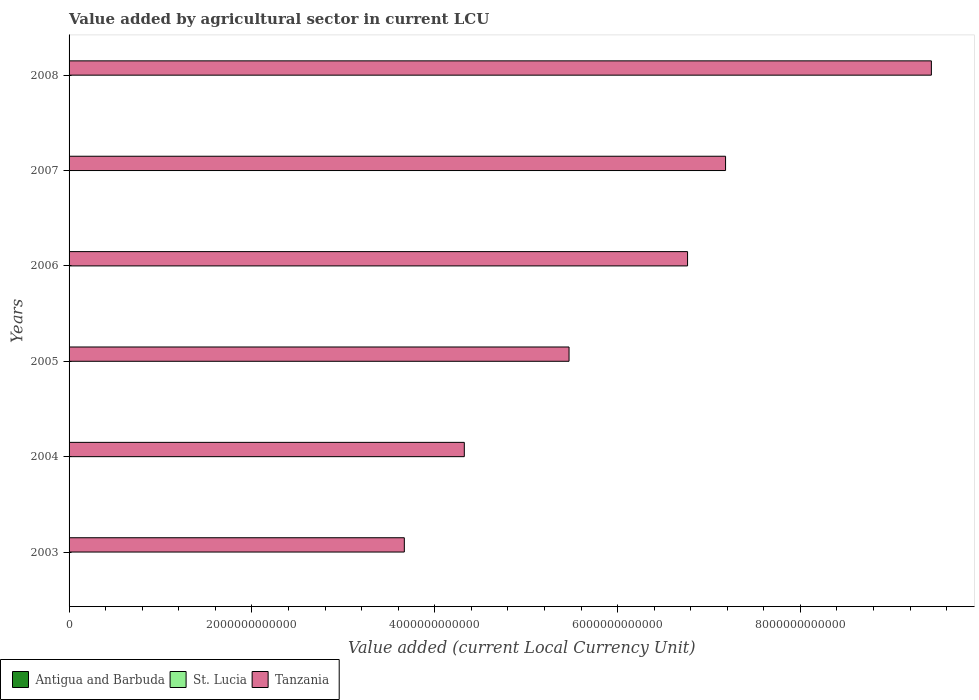How many different coloured bars are there?
Your answer should be very brief. 3. Are the number of bars per tick equal to the number of legend labels?
Your answer should be very brief. Yes. What is the label of the 3rd group of bars from the top?
Your answer should be very brief. 2006. What is the value added by agricultural sector in Antigua and Barbuda in 2005?
Your response must be concise. 4.85e+07. Across all years, what is the maximum value added by agricultural sector in Antigua and Barbuda?
Your response must be concise. 5.72e+07. Across all years, what is the minimum value added by agricultural sector in Tanzania?
Keep it short and to the point. 3.67e+12. What is the total value added by agricultural sector in Tanzania in the graph?
Provide a succinct answer. 3.68e+13. What is the difference between the value added by agricultural sector in St. Lucia in 2004 and that in 2008?
Provide a succinct answer. -2.80e+07. What is the difference between the value added by agricultural sector in St. Lucia in 2004 and the value added by agricultural sector in Antigua and Barbuda in 2007?
Make the answer very short. 3.47e+07. What is the average value added by agricultural sector in Tanzania per year?
Ensure brevity in your answer.  6.14e+12. In the year 2007, what is the difference between the value added by agricultural sector in Tanzania and value added by agricultural sector in Antigua and Barbuda?
Your response must be concise. 7.18e+12. What is the ratio of the value added by agricultural sector in St. Lucia in 2006 to that in 2007?
Provide a succinct answer. 1.01. Is the difference between the value added by agricultural sector in Tanzania in 2004 and 2008 greater than the difference between the value added by agricultural sector in Antigua and Barbuda in 2004 and 2008?
Provide a short and direct response. No. What is the difference between the highest and the second highest value added by agricultural sector in Antigua and Barbuda?
Give a very brief answer. 3.20e+05. What is the difference between the highest and the lowest value added by agricultural sector in St. Lucia?
Provide a succinct answer. 4.40e+07. What does the 2nd bar from the top in 2004 represents?
Ensure brevity in your answer.  St. Lucia. What does the 2nd bar from the bottom in 2008 represents?
Ensure brevity in your answer.  St. Lucia. Is it the case that in every year, the sum of the value added by agricultural sector in Antigua and Barbuda and value added by agricultural sector in St. Lucia is greater than the value added by agricultural sector in Tanzania?
Provide a succinct answer. No. How many bars are there?
Provide a succinct answer. 18. How many years are there in the graph?
Provide a succinct answer. 6. What is the difference between two consecutive major ticks on the X-axis?
Provide a short and direct response. 2.00e+12. Are the values on the major ticks of X-axis written in scientific E-notation?
Your answer should be compact. No. Does the graph contain any zero values?
Offer a terse response. No. Does the graph contain grids?
Your response must be concise. No. Where does the legend appear in the graph?
Your answer should be very brief. Bottom left. What is the title of the graph?
Offer a terse response. Value added by agricultural sector in current LCU. What is the label or title of the X-axis?
Your response must be concise. Value added (current Local Currency Unit). What is the label or title of the Y-axis?
Your response must be concise. Years. What is the Value added (current Local Currency Unit) in Antigua and Barbuda in 2003?
Your response must be concise. 4.04e+07. What is the Value added (current Local Currency Unit) in St. Lucia in 2003?
Provide a short and direct response. 8.72e+07. What is the Value added (current Local Currency Unit) in Tanzania in 2003?
Provide a succinct answer. 3.67e+12. What is the Value added (current Local Currency Unit) in Antigua and Barbuda in 2004?
Ensure brevity in your answer.  4.00e+07. What is the Value added (current Local Currency Unit) of St. Lucia in 2004?
Your response must be concise. 9.16e+07. What is the Value added (current Local Currency Unit) of Tanzania in 2004?
Your response must be concise. 4.32e+12. What is the Value added (current Local Currency Unit) of Antigua and Barbuda in 2005?
Keep it short and to the point. 4.85e+07. What is the Value added (current Local Currency Unit) in St. Lucia in 2005?
Give a very brief answer. 7.56e+07. What is the Value added (current Local Currency Unit) of Tanzania in 2005?
Give a very brief answer. 5.47e+12. What is the Value added (current Local Currency Unit) of Antigua and Barbuda in 2006?
Offer a terse response. 5.16e+07. What is the Value added (current Local Currency Unit) of St. Lucia in 2006?
Your answer should be very brief. 8.79e+07. What is the Value added (current Local Currency Unit) in Tanzania in 2006?
Your answer should be very brief. 6.77e+12. What is the Value added (current Local Currency Unit) of Antigua and Barbuda in 2007?
Your response must be concise. 5.69e+07. What is the Value added (current Local Currency Unit) in St. Lucia in 2007?
Your answer should be compact. 8.72e+07. What is the Value added (current Local Currency Unit) in Tanzania in 2007?
Offer a very short reply. 7.18e+12. What is the Value added (current Local Currency Unit) of Antigua and Barbuda in 2008?
Your answer should be very brief. 5.72e+07. What is the Value added (current Local Currency Unit) in St. Lucia in 2008?
Keep it short and to the point. 1.20e+08. What is the Value added (current Local Currency Unit) in Tanzania in 2008?
Keep it short and to the point. 9.43e+12. Across all years, what is the maximum Value added (current Local Currency Unit) of Antigua and Barbuda?
Keep it short and to the point. 5.72e+07. Across all years, what is the maximum Value added (current Local Currency Unit) of St. Lucia?
Offer a very short reply. 1.20e+08. Across all years, what is the maximum Value added (current Local Currency Unit) in Tanzania?
Provide a succinct answer. 9.43e+12. Across all years, what is the minimum Value added (current Local Currency Unit) in Antigua and Barbuda?
Your answer should be very brief. 4.00e+07. Across all years, what is the minimum Value added (current Local Currency Unit) of St. Lucia?
Your response must be concise. 7.56e+07. Across all years, what is the minimum Value added (current Local Currency Unit) in Tanzania?
Give a very brief answer. 3.67e+12. What is the total Value added (current Local Currency Unit) of Antigua and Barbuda in the graph?
Provide a succinct answer. 2.95e+08. What is the total Value added (current Local Currency Unit) of St. Lucia in the graph?
Offer a terse response. 5.49e+08. What is the total Value added (current Local Currency Unit) in Tanzania in the graph?
Provide a succinct answer. 3.68e+13. What is the difference between the Value added (current Local Currency Unit) of Antigua and Barbuda in 2003 and that in 2004?
Give a very brief answer. 4.45e+05. What is the difference between the Value added (current Local Currency Unit) in St. Lucia in 2003 and that in 2004?
Your response must be concise. -4.46e+06. What is the difference between the Value added (current Local Currency Unit) in Tanzania in 2003 and that in 2004?
Provide a short and direct response. -6.56e+11. What is the difference between the Value added (current Local Currency Unit) of Antigua and Barbuda in 2003 and that in 2005?
Provide a short and direct response. -8.10e+06. What is the difference between the Value added (current Local Currency Unit) of St. Lucia in 2003 and that in 2005?
Make the answer very short. 1.16e+07. What is the difference between the Value added (current Local Currency Unit) of Tanzania in 2003 and that in 2005?
Provide a succinct answer. -1.80e+12. What is the difference between the Value added (current Local Currency Unit) of Antigua and Barbuda in 2003 and that in 2006?
Your answer should be compact. -1.12e+07. What is the difference between the Value added (current Local Currency Unit) in St. Lucia in 2003 and that in 2006?
Keep it short and to the point. -7.20e+05. What is the difference between the Value added (current Local Currency Unit) in Tanzania in 2003 and that in 2006?
Your answer should be compact. -3.10e+12. What is the difference between the Value added (current Local Currency Unit) of Antigua and Barbuda in 2003 and that in 2007?
Provide a short and direct response. -1.65e+07. What is the difference between the Value added (current Local Currency Unit) in St. Lucia in 2003 and that in 2007?
Make the answer very short. -3.81e+04. What is the difference between the Value added (current Local Currency Unit) in Tanzania in 2003 and that in 2007?
Keep it short and to the point. -3.51e+12. What is the difference between the Value added (current Local Currency Unit) of Antigua and Barbuda in 2003 and that in 2008?
Your answer should be compact. -1.68e+07. What is the difference between the Value added (current Local Currency Unit) of St. Lucia in 2003 and that in 2008?
Offer a terse response. -3.24e+07. What is the difference between the Value added (current Local Currency Unit) of Tanzania in 2003 and that in 2008?
Make the answer very short. -5.77e+12. What is the difference between the Value added (current Local Currency Unit) in Antigua and Barbuda in 2004 and that in 2005?
Ensure brevity in your answer.  -8.54e+06. What is the difference between the Value added (current Local Currency Unit) of St. Lucia in 2004 and that in 2005?
Provide a succinct answer. 1.60e+07. What is the difference between the Value added (current Local Currency Unit) in Tanzania in 2004 and that in 2005?
Make the answer very short. -1.15e+12. What is the difference between the Value added (current Local Currency Unit) in Antigua and Barbuda in 2004 and that in 2006?
Provide a short and direct response. -1.17e+07. What is the difference between the Value added (current Local Currency Unit) in St. Lucia in 2004 and that in 2006?
Your answer should be very brief. 3.74e+06. What is the difference between the Value added (current Local Currency Unit) of Tanzania in 2004 and that in 2006?
Offer a very short reply. -2.44e+12. What is the difference between the Value added (current Local Currency Unit) in Antigua and Barbuda in 2004 and that in 2007?
Offer a terse response. -1.70e+07. What is the difference between the Value added (current Local Currency Unit) of St. Lucia in 2004 and that in 2007?
Your answer should be very brief. 4.42e+06. What is the difference between the Value added (current Local Currency Unit) of Tanzania in 2004 and that in 2007?
Your answer should be very brief. -2.86e+12. What is the difference between the Value added (current Local Currency Unit) of Antigua and Barbuda in 2004 and that in 2008?
Give a very brief answer. -1.73e+07. What is the difference between the Value added (current Local Currency Unit) of St. Lucia in 2004 and that in 2008?
Provide a short and direct response. -2.80e+07. What is the difference between the Value added (current Local Currency Unit) in Tanzania in 2004 and that in 2008?
Provide a succinct answer. -5.11e+12. What is the difference between the Value added (current Local Currency Unit) of Antigua and Barbuda in 2005 and that in 2006?
Give a very brief answer. -3.13e+06. What is the difference between the Value added (current Local Currency Unit) in St. Lucia in 2005 and that in 2006?
Make the answer very short. -1.23e+07. What is the difference between the Value added (current Local Currency Unit) in Tanzania in 2005 and that in 2006?
Ensure brevity in your answer.  -1.30e+12. What is the difference between the Value added (current Local Currency Unit) of Antigua and Barbuda in 2005 and that in 2007?
Your answer should be very brief. -8.41e+06. What is the difference between the Value added (current Local Currency Unit) in St. Lucia in 2005 and that in 2007?
Make the answer very short. -1.16e+07. What is the difference between the Value added (current Local Currency Unit) in Tanzania in 2005 and that in 2007?
Keep it short and to the point. -1.71e+12. What is the difference between the Value added (current Local Currency Unit) in Antigua and Barbuda in 2005 and that in 2008?
Provide a succinct answer. -8.73e+06. What is the difference between the Value added (current Local Currency Unit) of St. Lucia in 2005 and that in 2008?
Your answer should be compact. -4.40e+07. What is the difference between the Value added (current Local Currency Unit) of Tanzania in 2005 and that in 2008?
Offer a terse response. -3.96e+12. What is the difference between the Value added (current Local Currency Unit) in Antigua and Barbuda in 2006 and that in 2007?
Provide a succinct answer. -5.28e+06. What is the difference between the Value added (current Local Currency Unit) of St. Lucia in 2006 and that in 2007?
Your answer should be compact. 6.82e+05. What is the difference between the Value added (current Local Currency Unit) of Tanzania in 2006 and that in 2007?
Ensure brevity in your answer.  -4.16e+11. What is the difference between the Value added (current Local Currency Unit) in Antigua and Barbuda in 2006 and that in 2008?
Offer a terse response. -5.60e+06. What is the difference between the Value added (current Local Currency Unit) in St. Lucia in 2006 and that in 2008?
Your answer should be very brief. -3.17e+07. What is the difference between the Value added (current Local Currency Unit) of Tanzania in 2006 and that in 2008?
Give a very brief answer. -2.67e+12. What is the difference between the Value added (current Local Currency Unit) of Antigua and Barbuda in 2007 and that in 2008?
Ensure brevity in your answer.  -3.20e+05. What is the difference between the Value added (current Local Currency Unit) of St. Lucia in 2007 and that in 2008?
Provide a short and direct response. -3.24e+07. What is the difference between the Value added (current Local Currency Unit) of Tanzania in 2007 and that in 2008?
Provide a short and direct response. -2.25e+12. What is the difference between the Value added (current Local Currency Unit) of Antigua and Barbuda in 2003 and the Value added (current Local Currency Unit) of St. Lucia in 2004?
Your answer should be very brief. -5.12e+07. What is the difference between the Value added (current Local Currency Unit) of Antigua and Barbuda in 2003 and the Value added (current Local Currency Unit) of Tanzania in 2004?
Make the answer very short. -4.32e+12. What is the difference between the Value added (current Local Currency Unit) of St. Lucia in 2003 and the Value added (current Local Currency Unit) of Tanzania in 2004?
Provide a short and direct response. -4.32e+12. What is the difference between the Value added (current Local Currency Unit) in Antigua and Barbuda in 2003 and the Value added (current Local Currency Unit) in St. Lucia in 2005?
Your response must be concise. -3.51e+07. What is the difference between the Value added (current Local Currency Unit) in Antigua and Barbuda in 2003 and the Value added (current Local Currency Unit) in Tanzania in 2005?
Make the answer very short. -5.47e+12. What is the difference between the Value added (current Local Currency Unit) of St. Lucia in 2003 and the Value added (current Local Currency Unit) of Tanzania in 2005?
Your answer should be compact. -5.47e+12. What is the difference between the Value added (current Local Currency Unit) in Antigua and Barbuda in 2003 and the Value added (current Local Currency Unit) in St. Lucia in 2006?
Keep it short and to the point. -4.75e+07. What is the difference between the Value added (current Local Currency Unit) in Antigua and Barbuda in 2003 and the Value added (current Local Currency Unit) in Tanzania in 2006?
Keep it short and to the point. -6.77e+12. What is the difference between the Value added (current Local Currency Unit) in St. Lucia in 2003 and the Value added (current Local Currency Unit) in Tanzania in 2006?
Offer a very short reply. -6.77e+12. What is the difference between the Value added (current Local Currency Unit) in Antigua and Barbuda in 2003 and the Value added (current Local Currency Unit) in St. Lucia in 2007?
Keep it short and to the point. -4.68e+07. What is the difference between the Value added (current Local Currency Unit) of Antigua and Barbuda in 2003 and the Value added (current Local Currency Unit) of Tanzania in 2007?
Offer a terse response. -7.18e+12. What is the difference between the Value added (current Local Currency Unit) of St. Lucia in 2003 and the Value added (current Local Currency Unit) of Tanzania in 2007?
Offer a very short reply. -7.18e+12. What is the difference between the Value added (current Local Currency Unit) in Antigua and Barbuda in 2003 and the Value added (current Local Currency Unit) in St. Lucia in 2008?
Offer a very short reply. -7.92e+07. What is the difference between the Value added (current Local Currency Unit) of Antigua and Barbuda in 2003 and the Value added (current Local Currency Unit) of Tanzania in 2008?
Offer a very short reply. -9.43e+12. What is the difference between the Value added (current Local Currency Unit) of St. Lucia in 2003 and the Value added (current Local Currency Unit) of Tanzania in 2008?
Give a very brief answer. -9.43e+12. What is the difference between the Value added (current Local Currency Unit) of Antigua and Barbuda in 2004 and the Value added (current Local Currency Unit) of St. Lucia in 2005?
Your answer should be compact. -3.56e+07. What is the difference between the Value added (current Local Currency Unit) in Antigua and Barbuda in 2004 and the Value added (current Local Currency Unit) in Tanzania in 2005?
Keep it short and to the point. -5.47e+12. What is the difference between the Value added (current Local Currency Unit) of St. Lucia in 2004 and the Value added (current Local Currency Unit) of Tanzania in 2005?
Offer a very short reply. -5.47e+12. What is the difference between the Value added (current Local Currency Unit) in Antigua and Barbuda in 2004 and the Value added (current Local Currency Unit) in St. Lucia in 2006?
Provide a succinct answer. -4.79e+07. What is the difference between the Value added (current Local Currency Unit) of Antigua and Barbuda in 2004 and the Value added (current Local Currency Unit) of Tanzania in 2006?
Make the answer very short. -6.77e+12. What is the difference between the Value added (current Local Currency Unit) in St. Lucia in 2004 and the Value added (current Local Currency Unit) in Tanzania in 2006?
Your answer should be compact. -6.77e+12. What is the difference between the Value added (current Local Currency Unit) of Antigua and Barbuda in 2004 and the Value added (current Local Currency Unit) of St. Lucia in 2007?
Your answer should be compact. -4.72e+07. What is the difference between the Value added (current Local Currency Unit) of Antigua and Barbuda in 2004 and the Value added (current Local Currency Unit) of Tanzania in 2007?
Give a very brief answer. -7.18e+12. What is the difference between the Value added (current Local Currency Unit) in St. Lucia in 2004 and the Value added (current Local Currency Unit) in Tanzania in 2007?
Offer a terse response. -7.18e+12. What is the difference between the Value added (current Local Currency Unit) of Antigua and Barbuda in 2004 and the Value added (current Local Currency Unit) of St. Lucia in 2008?
Your answer should be very brief. -7.96e+07. What is the difference between the Value added (current Local Currency Unit) in Antigua and Barbuda in 2004 and the Value added (current Local Currency Unit) in Tanzania in 2008?
Keep it short and to the point. -9.43e+12. What is the difference between the Value added (current Local Currency Unit) of St. Lucia in 2004 and the Value added (current Local Currency Unit) of Tanzania in 2008?
Offer a terse response. -9.43e+12. What is the difference between the Value added (current Local Currency Unit) in Antigua and Barbuda in 2005 and the Value added (current Local Currency Unit) in St. Lucia in 2006?
Ensure brevity in your answer.  -3.94e+07. What is the difference between the Value added (current Local Currency Unit) in Antigua and Barbuda in 2005 and the Value added (current Local Currency Unit) in Tanzania in 2006?
Your response must be concise. -6.77e+12. What is the difference between the Value added (current Local Currency Unit) in St. Lucia in 2005 and the Value added (current Local Currency Unit) in Tanzania in 2006?
Your response must be concise. -6.77e+12. What is the difference between the Value added (current Local Currency Unit) of Antigua and Barbuda in 2005 and the Value added (current Local Currency Unit) of St. Lucia in 2007?
Keep it short and to the point. -3.87e+07. What is the difference between the Value added (current Local Currency Unit) in Antigua and Barbuda in 2005 and the Value added (current Local Currency Unit) in Tanzania in 2007?
Offer a very short reply. -7.18e+12. What is the difference between the Value added (current Local Currency Unit) in St. Lucia in 2005 and the Value added (current Local Currency Unit) in Tanzania in 2007?
Provide a succinct answer. -7.18e+12. What is the difference between the Value added (current Local Currency Unit) in Antigua and Barbuda in 2005 and the Value added (current Local Currency Unit) in St. Lucia in 2008?
Offer a very short reply. -7.11e+07. What is the difference between the Value added (current Local Currency Unit) of Antigua and Barbuda in 2005 and the Value added (current Local Currency Unit) of Tanzania in 2008?
Keep it short and to the point. -9.43e+12. What is the difference between the Value added (current Local Currency Unit) of St. Lucia in 2005 and the Value added (current Local Currency Unit) of Tanzania in 2008?
Ensure brevity in your answer.  -9.43e+12. What is the difference between the Value added (current Local Currency Unit) in Antigua and Barbuda in 2006 and the Value added (current Local Currency Unit) in St. Lucia in 2007?
Offer a very short reply. -3.56e+07. What is the difference between the Value added (current Local Currency Unit) of Antigua and Barbuda in 2006 and the Value added (current Local Currency Unit) of Tanzania in 2007?
Keep it short and to the point. -7.18e+12. What is the difference between the Value added (current Local Currency Unit) of St. Lucia in 2006 and the Value added (current Local Currency Unit) of Tanzania in 2007?
Offer a very short reply. -7.18e+12. What is the difference between the Value added (current Local Currency Unit) in Antigua and Barbuda in 2006 and the Value added (current Local Currency Unit) in St. Lucia in 2008?
Your answer should be compact. -6.79e+07. What is the difference between the Value added (current Local Currency Unit) of Antigua and Barbuda in 2006 and the Value added (current Local Currency Unit) of Tanzania in 2008?
Ensure brevity in your answer.  -9.43e+12. What is the difference between the Value added (current Local Currency Unit) in St. Lucia in 2006 and the Value added (current Local Currency Unit) in Tanzania in 2008?
Your answer should be compact. -9.43e+12. What is the difference between the Value added (current Local Currency Unit) of Antigua and Barbuda in 2007 and the Value added (current Local Currency Unit) of St. Lucia in 2008?
Provide a succinct answer. -6.27e+07. What is the difference between the Value added (current Local Currency Unit) in Antigua and Barbuda in 2007 and the Value added (current Local Currency Unit) in Tanzania in 2008?
Keep it short and to the point. -9.43e+12. What is the difference between the Value added (current Local Currency Unit) of St. Lucia in 2007 and the Value added (current Local Currency Unit) of Tanzania in 2008?
Keep it short and to the point. -9.43e+12. What is the average Value added (current Local Currency Unit) of Antigua and Barbuda per year?
Ensure brevity in your answer.  4.91e+07. What is the average Value added (current Local Currency Unit) in St. Lucia per year?
Your answer should be very brief. 9.15e+07. What is the average Value added (current Local Currency Unit) of Tanzania per year?
Provide a short and direct response. 6.14e+12. In the year 2003, what is the difference between the Value added (current Local Currency Unit) of Antigua and Barbuda and Value added (current Local Currency Unit) of St. Lucia?
Keep it short and to the point. -4.67e+07. In the year 2003, what is the difference between the Value added (current Local Currency Unit) in Antigua and Barbuda and Value added (current Local Currency Unit) in Tanzania?
Provide a succinct answer. -3.67e+12. In the year 2003, what is the difference between the Value added (current Local Currency Unit) in St. Lucia and Value added (current Local Currency Unit) in Tanzania?
Give a very brief answer. -3.67e+12. In the year 2004, what is the difference between the Value added (current Local Currency Unit) of Antigua and Barbuda and Value added (current Local Currency Unit) of St. Lucia?
Give a very brief answer. -5.16e+07. In the year 2004, what is the difference between the Value added (current Local Currency Unit) in Antigua and Barbuda and Value added (current Local Currency Unit) in Tanzania?
Ensure brevity in your answer.  -4.32e+12. In the year 2004, what is the difference between the Value added (current Local Currency Unit) in St. Lucia and Value added (current Local Currency Unit) in Tanzania?
Provide a succinct answer. -4.32e+12. In the year 2005, what is the difference between the Value added (current Local Currency Unit) of Antigua and Barbuda and Value added (current Local Currency Unit) of St. Lucia?
Offer a very short reply. -2.70e+07. In the year 2005, what is the difference between the Value added (current Local Currency Unit) of Antigua and Barbuda and Value added (current Local Currency Unit) of Tanzania?
Give a very brief answer. -5.47e+12. In the year 2005, what is the difference between the Value added (current Local Currency Unit) of St. Lucia and Value added (current Local Currency Unit) of Tanzania?
Provide a succinct answer. -5.47e+12. In the year 2006, what is the difference between the Value added (current Local Currency Unit) in Antigua and Barbuda and Value added (current Local Currency Unit) in St. Lucia?
Provide a short and direct response. -3.62e+07. In the year 2006, what is the difference between the Value added (current Local Currency Unit) of Antigua and Barbuda and Value added (current Local Currency Unit) of Tanzania?
Provide a succinct answer. -6.77e+12. In the year 2006, what is the difference between the Value added (current Local Currency Unit) in St. Lucia and Value added (current Local Currency Unit) in Tanzania?
Your answer should be compact. -6.77e+12. In the year 2007, what is the difference between the Value added (current Local Currency Unit) in Antigua and Barbuda and Value added (current Local Currency Unit) in St. Lucia?
Your answer should be very brief. -3.03e+07. In the year 2007, what is the difference between the Value added (current Local Currency Unit) of Antigua and Barbuda and Value added (current Local Currency Unit) of Tanzania?
Your answer should be very brief. -7.18e+12. In the year 2007, what is the difference between the Value added (current Local Currency Unit) of St. Lucia and Value added (current Local Currency Unit) of Tanzania?
Provide a short and direct response. -7.18e+12. In the year 2008, what is the difference between the Value added (current Local Currency Unit) of Antigua and Barbuda and Value added (current Local Currency Unit) of St. Lucia?
Provide a succinct answer. -6.23e+07. In the year 2008, what is the difference between the Value added (current Local Currency Unit) in Antigua and Barbuda and Value added (current Local Currency Unit) in Tanzania?
Offer a terse response. -9.43e+12. In the year 2008, what is the difference between the Value added (current Local Currency Unit) of St. Lucia and Value added (current Local Currency Unit) of Tanzania?
Your answer should be compact. -9.43e+12. What is the ratio of the Value added (current Local Currency Unit) in Antigua and Barbuda in 2003 to that in 2004?
Your answer should be very brief. 1.01. What is the ratio of the Value added (current Local Currency Unit) of St. Lucia in 2003 to that in 2004?
Make the answer very short. 0.95. What is the ratio of the Value added (current Local Currency Unit) of Tanzania in 2003 to that in 2004?
Give a very brief answer. 0.85. What is the ratio of the Value added (current Local Currency Unit) of Antigua and Barbuda in 2003 to that in 2005?
Offer a terse response. 0.83. What is the ratio of the Value added (current Local Currency Unit) in St. Lucia in 2003 to that in 2005?
Make the answer very short. 1.15. What is the ratio of the Value added (current Local Currency Unit) in Tanzania in 2003 to that in 2005?
Give a very brief answer. 0.67. What is the ratio of the Value added (current Local Currency Unit) of Antigua and Barbuda in 2003 to that in 2006?
Offer a very short reply. 0.78. What is the ratio of the Value added (current Local Currency Unit) of Tanzania in 2003 to that in 2006?
Ensure brevity in your answer.  0.54. What is the ratio of the Value added (current Local Currency Unit) of Antigua and Barbuda in 2003 to that in 2007?
Your answer should be compact. 0.71. What is the ratio of the Value added (current Local Currency Unit) in St. Lucia in 2003 to that in 2007?
Provide a short and direct response. 1. What is the ratio of the Value added (current Local Currency Unit) of Tanzania in 2003 to that in 2007?
Offer a terse response. 0.51. What is the ratio of the Value added (current Local Currency Unit) of Antigua and Barbuda in 2003 to that in 2008?
Your answer should be compact. 0.71. What is the ratio of the Value added (current Local Currency Unit) of St. Lucia in 2003 to that in 2008?
Your answer should be compact. 0.73. What is the ratio of the Value added (current Local Currency Unit) in Tanzania in 2003 to that in 2008?
Offer a very short reply. 0.39. What is the ratio of the Value added (current Local Currency Unit) of Antigua and Barbuda in 2004 to that in 2005?
Your answer should be compact. 0.82. What is the ratio of the Value added (current Local Currency Unit) in St. Lucia in 2004 to that in 2005?
Your response must be concise. 1.21. What is the ratio of the Value added (current Local Currency Unit) in Tanzania in 2004 to that in 2005?
Keep it short and to the point. 0.79. What is the ratio of the Value added (current Local Currency Unit) in Antigua and Barbuda in 2004 to that in 2006?
Provide a succinct answer. 0.77. What is the ratio of the Value added (current Local Currency Unit) in St. Lucia in 2004 to that in 2006?
Ensure brevity in your answer.  1.04. What is the ratio of the Value added (current Local Currency Unit) of Tanzania in 2004 to that in 2006?
Offer a terse response. 0.64. What is the ratio of the Value added (current Local Currency Unit) of Antigua and Barbuda in 2004 to that in 2007?
Give a very brief answer. 0.7. What is the ratio of the Value added (current Local Currency Unit) in St. Lucia in 2004 to that in 2007?
Ensure brevity in your answer.  1.05. What is the ratio of the Value added (current Local Currency Unit) of Tanzania in 2004 to that in 2007?
Offer a terse response. 0.6. What is the ratio of the Value added (current Local Currency Unit) of Antigua and Barbuda in 2004 to that in 2008?
Offer a terse response. 0.7. What is the ratio of the Value added (current Local Currency Unit) in St. Lucia in 2004 to that in 2008?
Your answer should be very brief. 0.77. What is the ratio of the Value added (current Local Currency Unit) in Tanzania in 2004 to that in 2008?
Ensure brevity in your answer.  0.46. What is the ratio of the Value added (current Local Currency Unit) of Antigua and Barbuda in 2005 to that in 2006?
Give a very brief answer. 0.94. What is the ratio of the Value added (current Local Currency Unit) in St. Lucia in 2005 to that in 2006?
Ensure brevity in your answer.  0.86. What is the ratio of the Value added (current Local Currency Unit) in Tanzania in 2005 to that in 2006?
Offer a very short reply. 0.81. What is the ratio of the Value added (current Local Currency Unit) in Antigua and Barbuda in 2005 to that in 2007?
Keep it short and to the point. 0.85. What is the ratio of the Value added (current Local Currency Unit) in St. Lucia in 2005 to that in 2007?
Provide a succinct answer. 0.87. What is the ratio of the Value added (current Local Currency Unit) of Tanzania in 2005 to that in 2007?
Offer a very short reply. 0.76. What is the ratio of the Value added (current Local Currency Unit) of Antigua and Barbuda in 2005 to that in 2008?
Offer a very short reply. 0.85. What is the ratio of the Value added (current Local Currency Unit) of St. Lucia in 2005 to that in 2008?
Provide a succinct answer. 0.63. What is the ratio of the Value added (current Local Currency Unit) in Tanzania in 2005 to that in 2008?
Ensure brevity in your answer.  0.58. What is the ratio of the Value added (current Local Currency Unit) in Antigua and Barbuda in 2006 to that in 2007?
Ensure brevity in your answer.  0.91. What is the ratio of the Value added (current Local Currency Unit) in St. Lucia in 2006 to that in 2007?
Make the answer very short. 1.01. What is the ratio of the Value added (current Local Currency Unit) in Tanzania in 2006 to that in 2007?
Offer a terse response. 0.94. What is the ratio of the Value added (current Local Currency Unit) in Antigua and Barbuda in 2006 to that in 2008?
Provide a short and direct response. 0.9. What is the ratio of the Value added (current Local Currency Unit) in St. Lucia in 2006 to that in 2008?
Your response must be concise. 0.73. What is the ratio of the Value added (current Local Currency Unit) in Tanzania in 2006 to that in 2008?
Offer a terse response. 0.72. What is the ratio of the Value added (current Local Currency Unit) in St. Lucia in 2007 to that in 2008?
Provide a succinct answer. 0.73. What is the ratio of the Value added (current Local Currency Unit) in Tanzania in 2007 to that in 2008?
Your answer should be very brief. 0.76. What is the difference between the highest and the second highest Value added (current Local Currency Unit) of Antigua and Barbuda?
Keep it short and to the point. 3.20e+05. What is the difference between the highest and the second highest Value added (current Local Currency Unit) of St. Lucia?
Make the answer very short. 2.80e+07. What is the difference between the highest and the second highest Value added (current Local Currency Unit) in Tanzania?
Provide a succinct answer. 2.25e+12. What is the difference between the highest and the lowest Value added (current Local Currency Unit) in Antigua and Barbuda?
Your answer should be compact. 1.73e+07. What is the difference between the highest and the lowest Value added (current Local Currency Unit) in St. Lucia?
Offer a very short reply. 4.40e+07. What is the difference between the highest and the lowest Value added (current Local Currency Unit) in Tanzania?
Provide a short and direct response. 5.77e+12. 